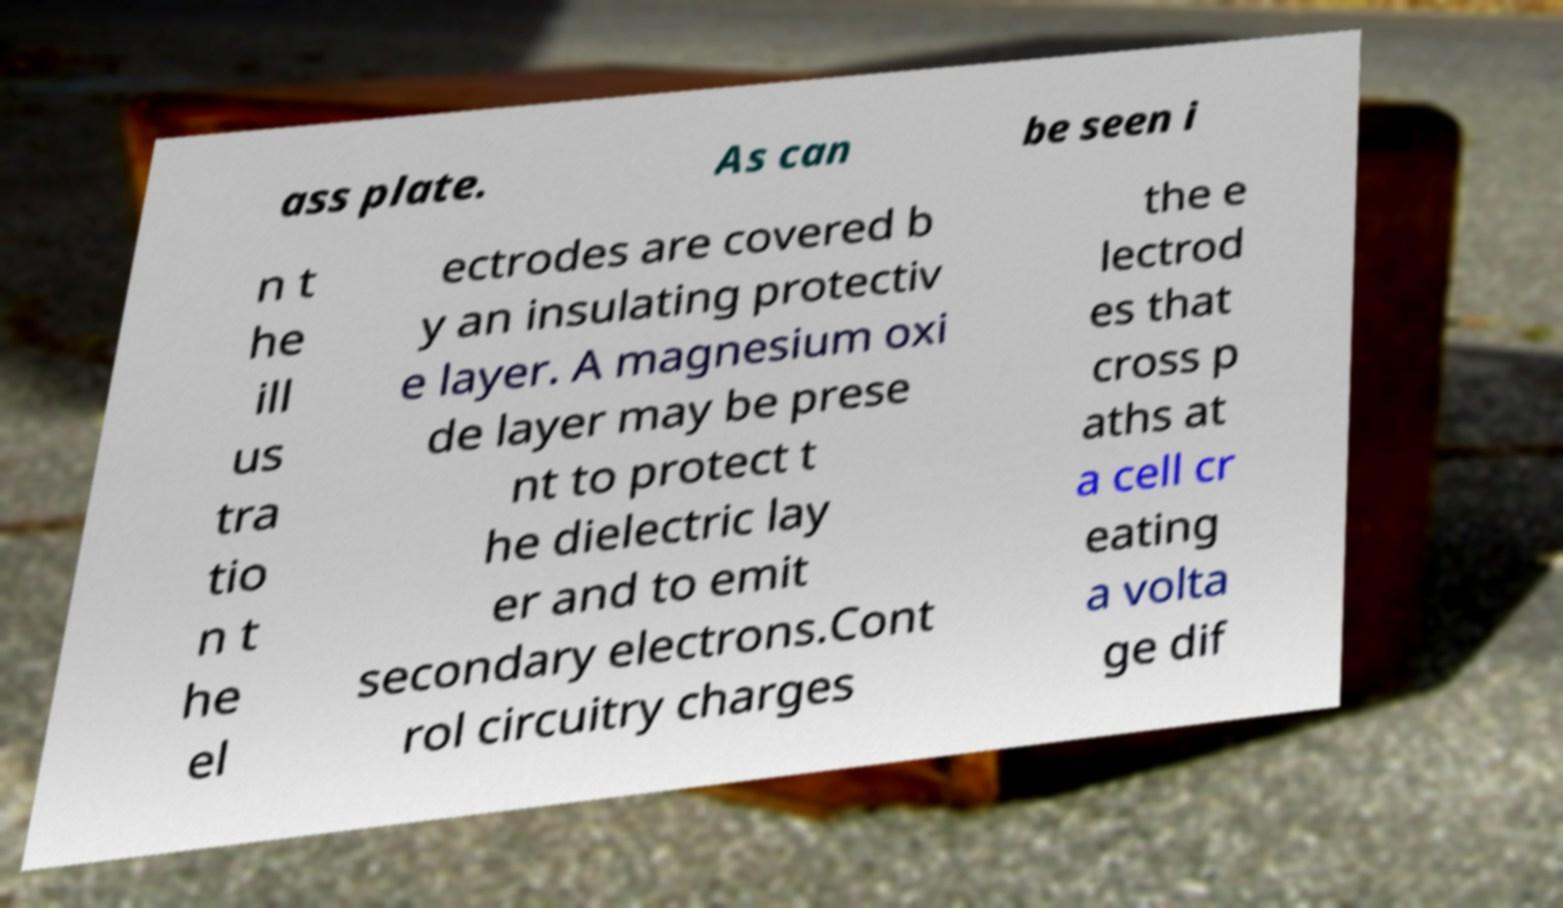Please read and relay the text visible in this image. What does it say? ass plate. As can be seen i n t he ill us tra tio n t he el ectrodes are covered b y an insulating protectiv e layer. A magnesium oxi de layer may be prese nt to protect t he dielectric lay er and to emit secondary electrons.Cont rol circuitry charges the e lectrod es that cross p aths at a cell cr eating a volta ge dif 